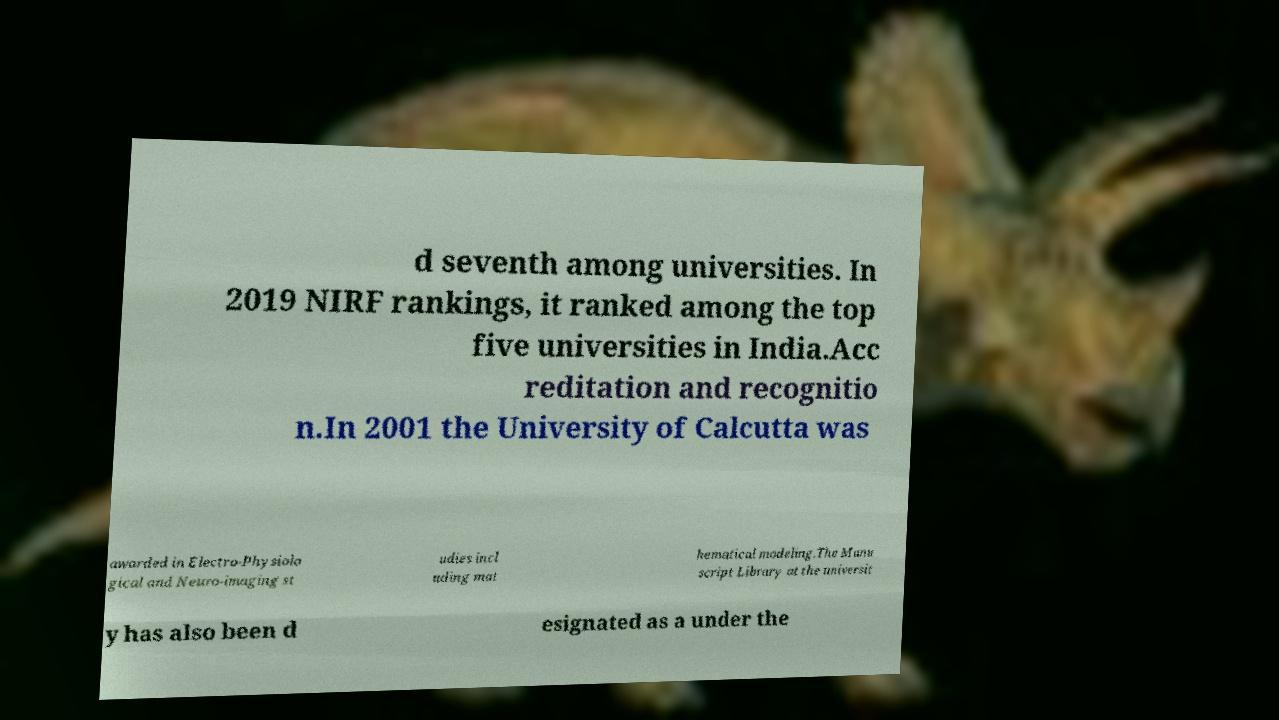Please read and relay the text visible in this image. What does it say? d seventh among universities. In 2019 NIRF rankings, it ranked among the top five universities in India.Acc reditation and recognitio n.In 2001 the University of Calcutta was awarded in Electro-Physiolo gical and Neuro-imaging st udies incl uding mat hematical modeling.The Manu script Library at the universit y has also been d esignated as a under the 